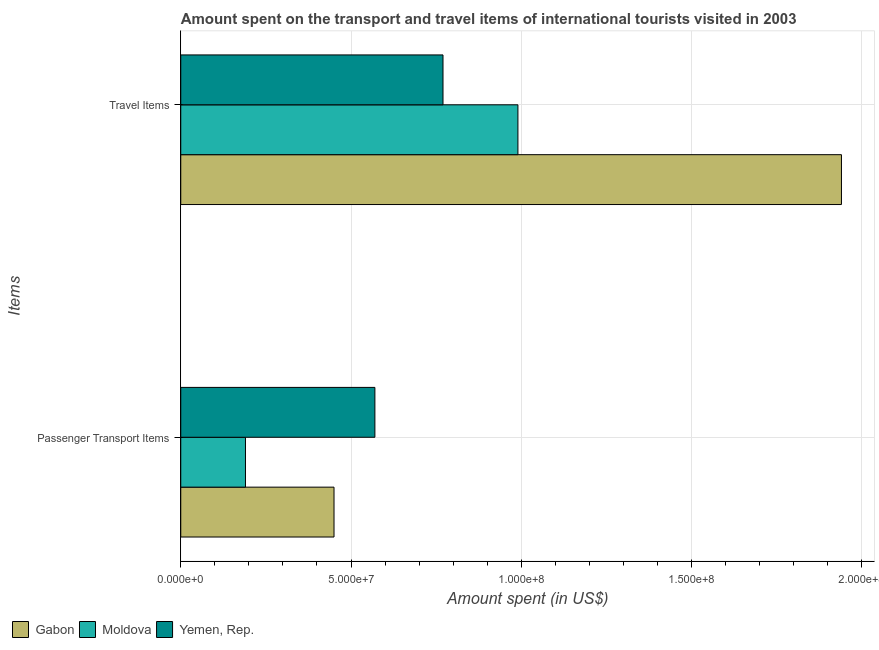Are the number of bars per tick equal to the number of legend labels?
Provide a short and direct response. Yes. What is the label of the 1st group of bars from the top?
Provide a succinct answer. Travel Items. What is the amount spent on passenger transport items in Moldova?
Offer a terse response. 1.90e+07. Across all countries, what is the maximum amount spent on passenger transport items?
Ensure brevity in your answer.  5.70e+07. Across all countries, what is the minimum amount spent in travel items?
Provide a short and direct response. 7.70e+07. In which country was the amount spent in travel items maximum?
Keep it short and to the point. Gabon. In which country was the amount spent on passenger transport items minimum?
Offer a very short reply. Moldova. What is the total amount spent in travel items in the graph?
Ensure brevity in your answer.  3.70e+08. What is the difference between the amount spent on passenger transport items in Gabon and that in Yemen, Rep.?
Offer a very short reply. -1.20e+07. What is the difference between the amount spent in travel items in Gabon and the amount spent on passenger transport items in Yemen, Rep.?
Your response must be concise. 1.37e+08. What is the average amount spent in travel items per country?
Offer a terse response. 1.23e+08. What is the difference between the amount spent in travel items and amount spent on passenger transport items in Gabon?
Provide a succinct answer. 1.49e+08. In how many countries, is the amount spent on passenger transport items greater than 40000000 US$?
Keep it short and to the point. 2. What is the ratio of the amount spent on passenger transport items in Moldova to that in Gabon?
Give a very brief answer. 0.42. Is the amount spent on passenger transport items in Gabon less than that in Moldova?
Give a very brief answer. No. In how many countries, is the amount spent on passenger transport items greater than the average amount spent on passenger transport items taken over all countries?
Your answer should be very brief. 2. What does the 1st bar from the top in Travel Items represents?
Ensure brevity in your answer.  Yemen, Rep. What does the 1st bar from the bottom in Travel Items represents?
Give a very brief answer. Gabon. How many bars are there?
Make the answer very short. 6. Does the graph contain any zero values?
Offer a very short reply. No. Where does the legend appear in the graph?
Your response must be concise. Bottom left. How many legend labels are there?
Provide a succinct answer. 3. What is the title of the graph?
Provide a short and direct response. Amount spent on the transport and travel items of international tourists visited in 2003. Does "Cameroon" appear as one of the legend labels in the graph?
Provide a succinct answer. No. What is the label or title of the X-axis?
Your response must be concise. Amount spent (in US$). What is the label or title of the Y-axis?
Your answer should be very brief. Items. What is the Amount spent (in US$) of Gabon in Passenger Transport Items?
Give a very brief answer. 4.50e+07. What is the Amount spent (in US$) of Moldova in Passenger Transport Items?
Ensure brevity in your answer.  1.90e+07. What is the Amount spent (in US$) of Yemen, Rep. in Passenger Transport Items?
Your response must be concise. 5.70e+07. What is the Amount spent (in US$) in Gabon in Travel Items?
Your answer should be very brief. 1.94e+08. What is the Amount spent (in US$) in Moldova in Travel Items?
Your answer should be very brief. 9.90e+07. What is the Amount spent (in US$) in Yemen, Rep. in Travel Items?
Make the answer very short. 7.70e+07. Across all Items, what is the maximum Amount spent (in US$) in Gabon?
Your response must be concise. 1.94e+08. Across all Items, what is the maximum Amount spent (in US$) in Moldova?
Provide a short and direct response. 9.90e+07. Across all Items, what is the maximum Amount spent (in US$) in Yemen, Rep.?
Make the answer very short. 7.70e+07. Across all Items, what is the minimum Amount spent (in US$) of Gabon?
Make the answer very short. 4.50e+07. Across all Items, what is the minimum Amount spent (in US$) of Moldova?
Give a very brief answer. 1.90e+07. Across all Items, what is the minimum Amount spent (in US$) in Yemen, Rep.?
Provide a succinct answer. 5.70e+07. What is the total Amount spent (in US$) in Gabon in the graph?
Offer a very short reply. 2.39e+08. What is the total Amount spent (in US$) of Moldova in the graph?
Your answer should be compact. 1.18e+08. What is the total Amount spent (in US$) of Yemen, Rep. in the graph?
Provide a short and direct response. 1.34e+08. What is the difference between the Amount spent (in US$) of Gabon in Passenger Transport Items and that in Travel Items?
Keep it short and to the point. -1.49e+08. What is the difference between the Amount spent (in US$) of Moldova in Passenger Transport Items and that in Travel Items?
Provide a short and direct response. -8.00e+07. What is the difference between the Amount spent (in US$) of Yemen, Rep. in Passenger Transport Items and that in Travel Items?
Offer a terse response. -2.00e+07. What is the difference between the Amount spent (in US$) in Gabon in Passenger Transport Items and the Amount spent (in US$) in Moldova in Travel Items?
Offer a very short reply. -5.40e+07. What is the difference between the Amount spent (in US$) in Gabon in Passenger Transport Items and the Amount spent (in US$) in Yemen, Rep. in Travel Items?
Offer a very short reply. -3.20e+07. What is the difference between the Amount spent (in US$) of Moldova in Passenger Transport Items and the Amount spent (in US$) of Yemen, Rep. in Travel Items?
Provide a succinct answer. -5.80e+07. What is the average Amount spent (in US$) of Gabon per Items?
Keep it short and to the point. 1.20e+08. What is the average Amount spent (in US$) in Moldova per Items?
Give a very brief answer. 5.90e+07. What is the average Amount spent (in US$) in Yemen, Rep. per Items?
Provide a succinct answer. 6.70e+07. What is the difference between the Amount spent (in US$) in Gabon and Amount spent (in US$) in Moldova in Passenger Transport Items?
Keep it short and to the point. 2.60e+07. What is the difference between the Amount spent (in US$) of Gabon and Amount spent (in US$) of Yemen, Rep. in Passenger Transport Items?
Your answer should be compact. -1.20e+07. What is the difference between the Amount spent (in US$) in Moldova and Amount spent (in US$) in Yemen, Rep. in Passenger Transport Items?
Your response must be concise. -3.80e+07. What is the difference between the Amount spent (in US$) in Gabon and Amount spent (in US$) in Moldova in Travel Items?
Give a very brief answer. 9.50e+07. What is the difference between the Amount spent (in US$) of Gabon and Amount spent (in US$) of Yemen, Rep. in Travel Items?
Your answer should be very brief. 1.17e+08. What is the difference between the Amount spent (in US$) of Moldova and Amount spent (in US$) of Yemen, Rep. in Travel Items?
Provide a short and direct response. 2.20e+07. What is the ratio of the Amount spent (in US$) in Gabon in Passenger Transport Items to that in Travel Items?
Offer a very short reply. 0.23. What is the ratio of the Amount spent (in US$) in Moldova in Passenger Transport Items to that in Travel Items?
Make the answer very short. 0.19. What is the ratio of the Amount spent (in US$) of Yemen, Rep. in Passenger Transport Items to that in Travel Items?
Your response must be concise. 0.74. What is the difference between the highest and the second highest Amount spent (in US$) of Gabon?
Offer a very short reply. 1.49e+08. What is the difference between the highest and the second highest Amount spent (in US$) of Moldova?
Ensure brevity in your answer.  8.00e+07. What is the difference between the highest and the lowest Amount spent (in US$) of Gabon?
Provide a short and direct response. 1.49e+08. What is the difference between the highest and the lowest Amount spent (in US$) of Moldova?
Keep it short and to the point. 8.00e+07. What is the difference between the highest and the lowest Amount spent (in US$) in Yemen, Rep.?
Your answer should be very brief. 2.00e+07. 